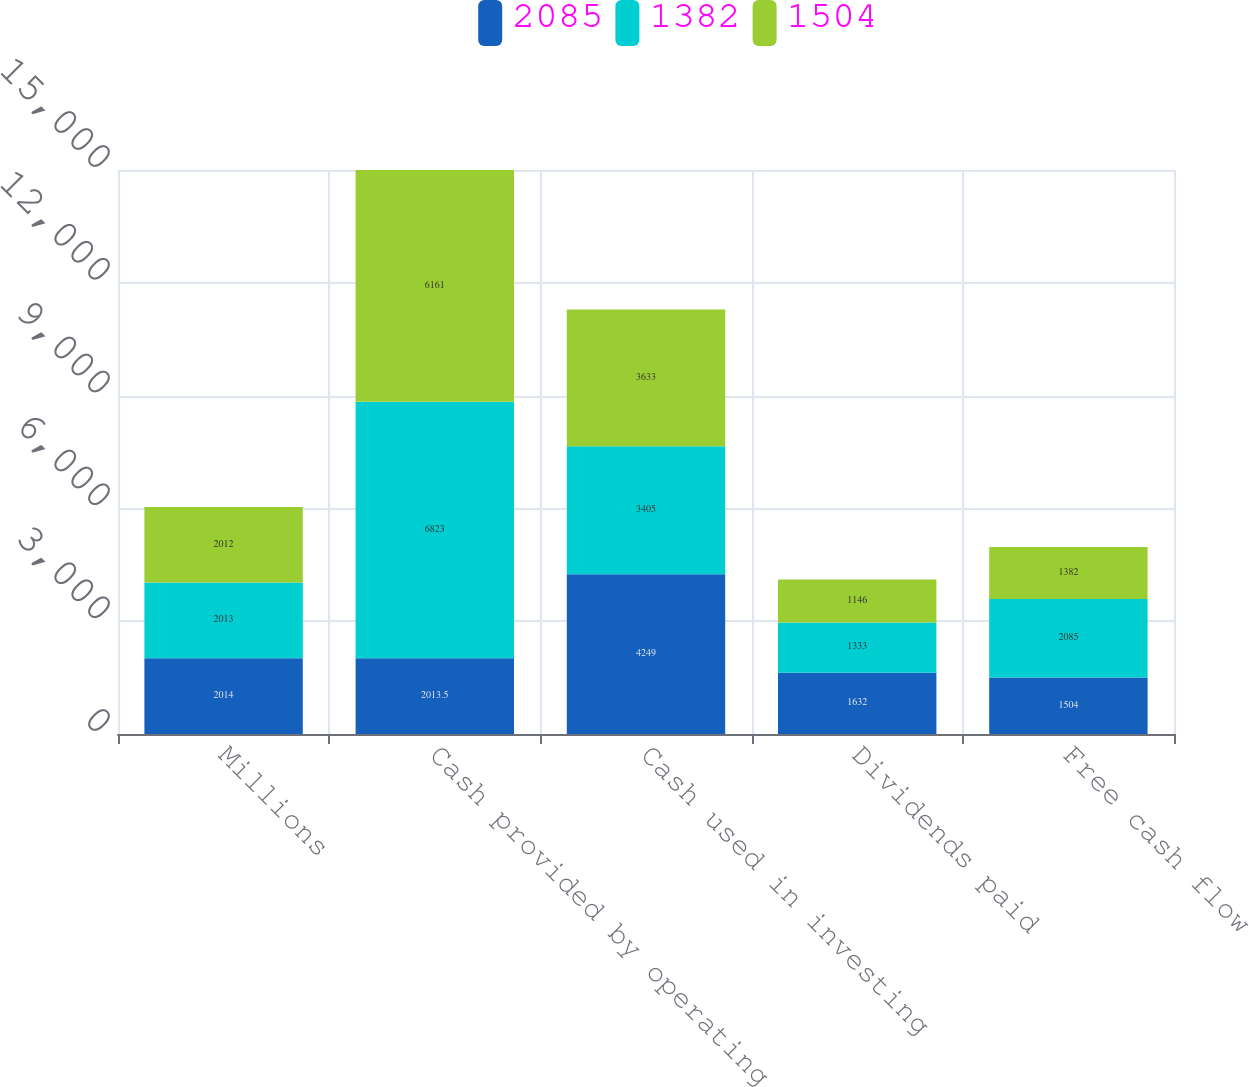<chart> <loc_0><loc_0><loc_500><loc_500><stacked_bar_chart><ecel><fcel>Millions<fcel>Cash provided by operating<fcel>Cash used in investing<fcel>Dividends paid<fcel>Free cash flow<nl><fcel>2085<fcel>2014<fcel>2013.5<fcel>4249<fcel>1632<fcel>1504<nl><fcel>1382<fcel>2013<fcel>6823<fcel>3405<fcel>1333<fcel>2085<nl><fcel>1504<fcel>2012<fcel>6161<fcel>3633<fcel>1146<fcel>1382<nl></chart> 